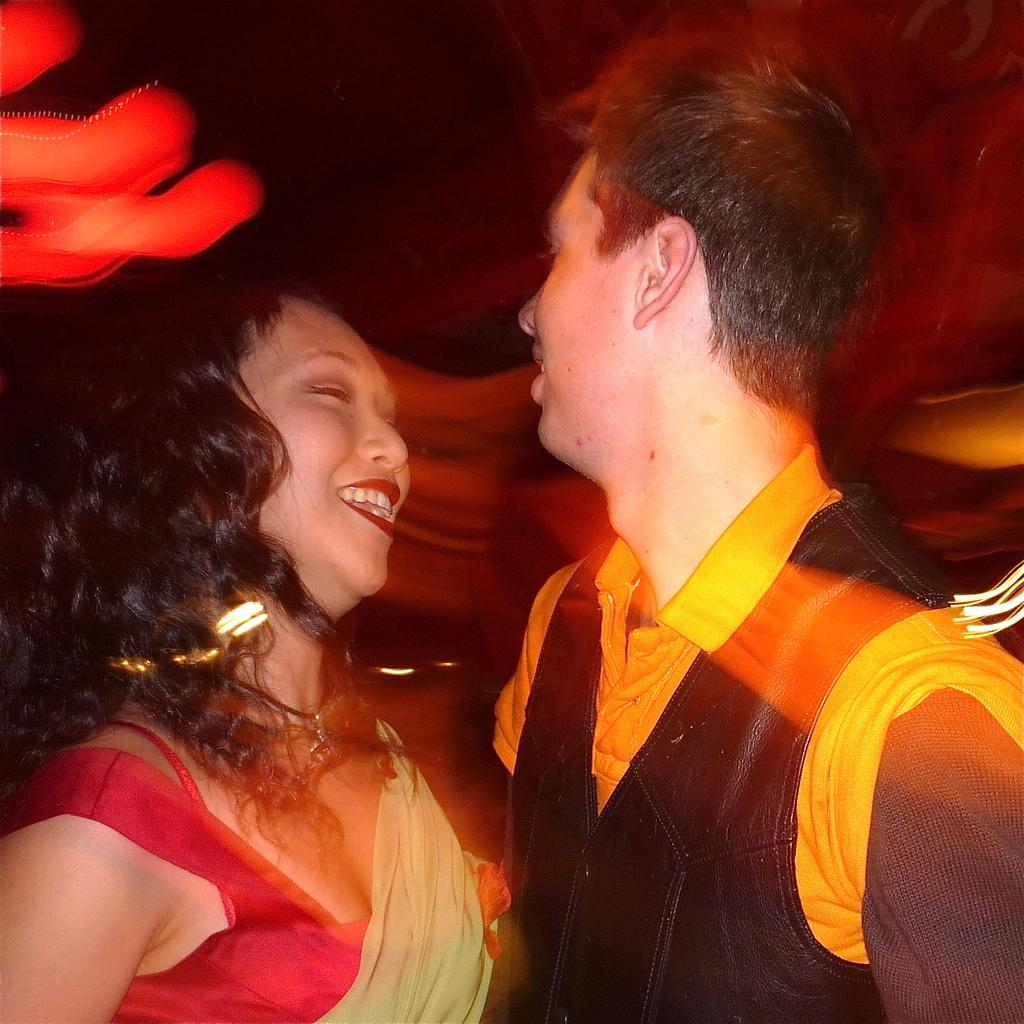How many people are present in the image? There are two people in the image, a man and a woman. Can you describe the individuals in the image? The image features a man and a woman. What might the man and woman be doing in the image? The specific activity of the man and woman cannot be determined from the provided facts. What color is the orange that the woman is holding in the image? There is no orange present in the image; it only features a man and a woman. 